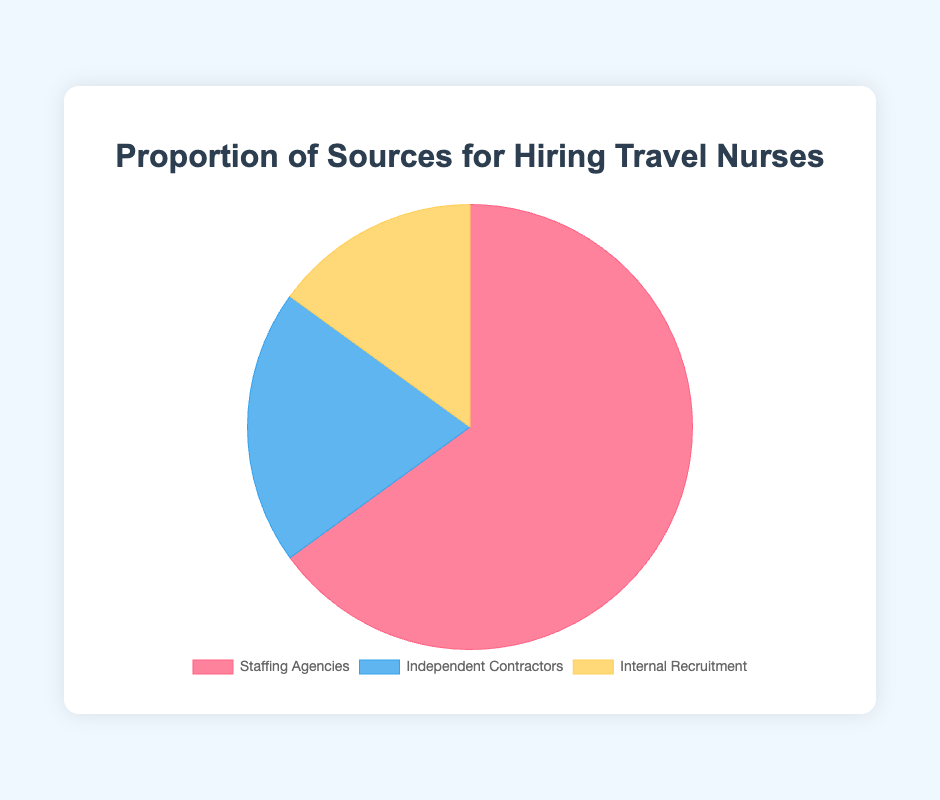What proportion of travel nurses are hired from staffing agencies? Staffing agencies account for 65% of the hiring sources for travel nurses, as represented by the largest segment in the pie chart.
Answer: 65% What is the combined proportion of travel nurses hired through independent contractors and internal recruitment? The proportion for independent contractors is 20%, and for internal recruitment, it is 15%. Adding these together gives 20% + 15% = 35%.
Answer: 35% Which source contributes the least to hiring travel nurses? By examining the smallest segment in the pie chart, we find that internal recruitment contributes the least, at 15%.
Answer: Internal Recruitment Is the proportion of travel nurses hired through staffing agencies greater than the sum of those hired through independent contractors and internal recruitment? Staffing agencies account for 65%, and the sum of independent contractors and internal recruitment is 35%. Since 65% is greater than 35%, staffing agencies have a greater proportion.
Answer: Yes Which color represents the segment for independent contractors, and what is its percentage? The segment for independent contractors is represented by blue, and it accounts for 20% of the travel nurse hiring sources.
Answer: Blue, 20% How does the proportion of travel nurses hired through independent contractors compare to those hired through staffing agencies? Independent contractors account for 20% while staffing agencies account for 65%. Therefore, staffing agencies hire a greater proportion of travel nurses.
Answer: Staffing agencies hire more By how much does the proportion of staffing agencies exceed that of internal recruitment? Staffing agencies account for 65%, and internal recruitment accounts for 15%. The difference between these proportions is 65% - 15% = 50%.
Answer: 50% If the internal recruitment proportion increased by 10%, how would its new proportion compare to the independent contractors' current proportion? Increasing internal recruitment's proportion by 10% results in 15% + 10% = 25%. This new proportion (25%) is now greater than the current proportion for independent contractors (20%).
Answer: Internals recruitment would be greater Which segment represents internal recruitment, and what proportion of the chart does it cover? The segment representing internal recruitment is yellow and it covers 15% of the pie chart.
Answer: Yellow, 15% What is the average proportion for the three hiring sources? Adding the proportions: 65% (staffing agencies) + 20% (independent contractors) + 15% (internal recruitment) = 100%. Dividing by 3 gives 100% / 3 ≈ 33.33%.
Answer: 33.33% 